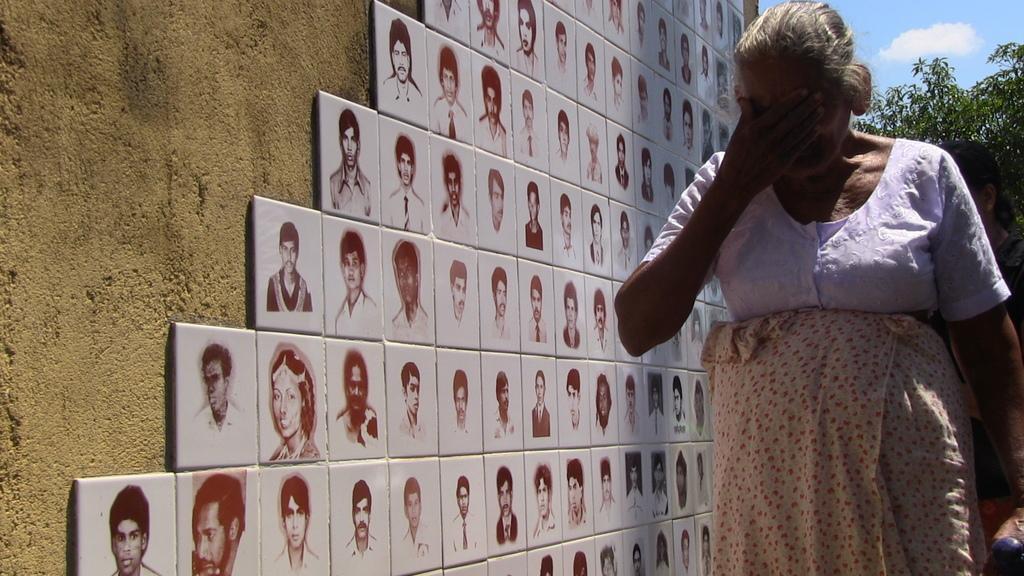Could you give a brief overview of what you see in this image? In the foreground of this image, there is an old woman on the right. On the left, there are tiles on which there are pictures of people on the wall. 